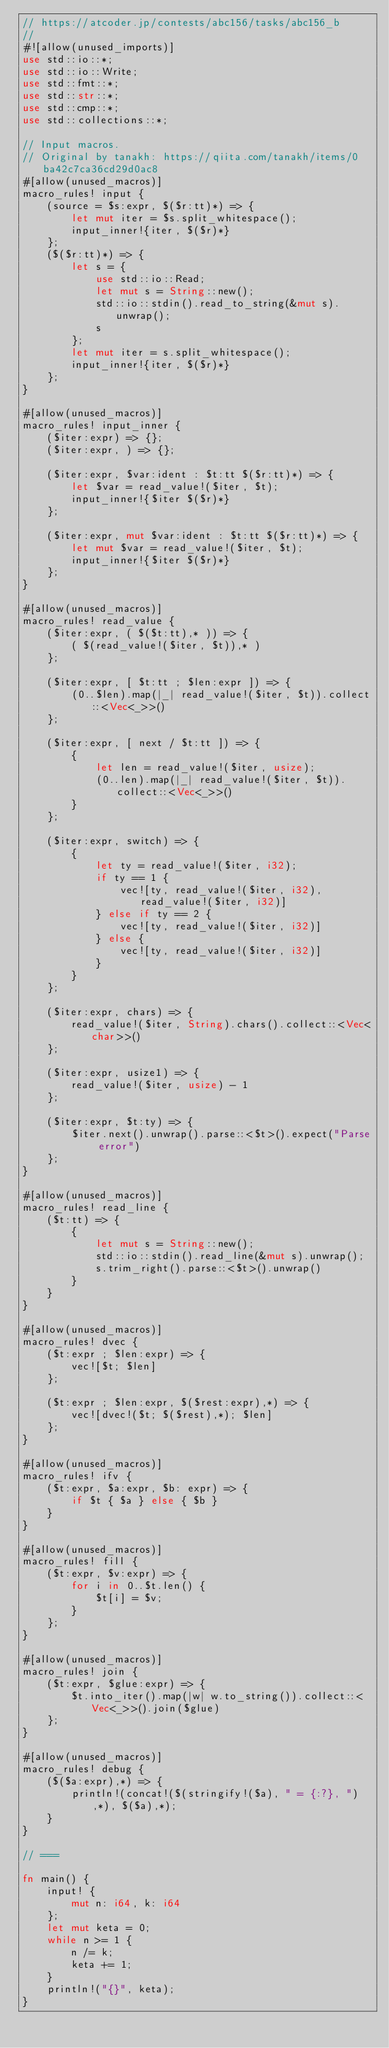Convert code to text. <code><loc_0><loc_0><loc_500><loc_500><_Rust_>// https://atcoder.jp/contests/abc156/tasks/abc156_b
//
#![allow(unused_imports)]
use std::io::*;
use std::io::Write;
use std::fmt::*;
use std::str::*;
use std::cmp::*;
use std::collections::*;

// Input macros.
// Original by tanakh: https://qiita.com/tanakh/items/0ba42c7ca36cd29d0ac8
#[allow(unused_macros)]
macro_rules! input {
    (source = $s:expr, $($r:tt)*) => {
        let mut iter = $s.split_whitespace();
        input_inner!{iter, $($r)*}
    };
    ($($r:tt)*) => {
        let s = {
            use std::io::Read;
            let mut s = String::new();
            std::io::stdin().read_to_string(&mut s).unwrap();
            s
        };
        let mut iter = s.split_whitespace();
        input_inner!{iter, $($r)*}
    };
}

#[allow(unused_macros)]
macro_rules! input_inner {
    ($iter:expr) => {};
    ($iter:expr, ) => {};

    ($iter:expr, $var:ident : $t:tt $($r:tt)*) => {
        let $var = read_value!($iter, $t);
        input_inner!{$iter $($r)*}
    };

    ($iter:expr, mut $var:ident : $t:tt $($r:tt)*) => {
        let mut $var = read_value!($iter, $t);
        input_inner!{$iter $($r)*}
    };
}

#[allow(unused_macros)]
macro_rules! read_value {
    ($iter:expr, ( $($t:tt),* )) => {
        ( $(read_value!($iter, $t)),* )
    };

    ($iter:expr, [ $t:tt ; $len:expr ]) => {
        (0..$len).map(|_| read_value!($iter, $t)).collect::<Vec<_>>()
    };

    ($iter:expr, [ next / $t:tt ]) => {
        {
            let len = read_value!($iter, usize);
            (0..len).map(|_| read_value!($iter, $t)).collect::<Vec<_>>()
        }
    };

    ($iter:expr, switch) => {
        {
            let ty = read_value!($iter, i32);
            if ty == 1 {
                vec![ty, read_value!($iter, i32), read_value!($iter, i32)]
            } else if ty == 2 {
                vec![ty, read_value!($iter, i32)]
            } else {
                vec![ty, read_value!($iter, i32)]
            }
        }
    };

    ($iter:expr, chars) => {
        read_value!($iter, String).chars().collect::<Vec<char>>()
    };

    ($iter:expr, usize1) => {
        read_value!($iter, usize) - 1
    };

    ($iter:expr, $t:ty) => {
        $iter.next().unwrap().parse::<$t>().expect("Parse error")
    };
}

#[allow(unused_macros)]
macro_rules! read_line {
    ($t:tt) => {
        {
            let mut s = String::new();
            std::io::stdin().read_line(&mut s).unwrap();
            s.trim_right().parse::<$t>().unwrap()
        }
    }
}

#[allow(unused_macros)]
macro_rules! dvec {
    ($t:expr ; $len:expr) => {
        vec![$t; $len]
    };

    ($t:expr ; $len:expr, $($rest:expr),*) => {
        vec![dvec!($t; $($rest),*); $len]
    };
}

#[allow(unused_macros)]
macro_rules! ifv {
    ($t:expr, $a:expr, $b: expr) => {
        if $t { $a } else { $b }
    }
}

#[allow(unused_macros)]
macro_rules! fill {
    ($t:expr, $v:expr) => {
        for i in 0..$t.len() {
            $t[i] = $v;
        }
    };
}

#[allow(unused_macros)]
macro_rules! join {
    ($t:expr, $glue:expr) => {
        $t.into_iter().map(|w| w.to_string()).collect::<Vec<_>>().join($glue)
    };
}

#[allow(unused_macros)]
macro_rules! debug {
    ($($a:expr),*) => {
        println!(concat!($(stringify!($a), " = {:?}, "),*), $($a),*);
    }
}

// ===

fn main() {
    input! {
        mut n: i64, k: i64
    };
    let mut keta = 0;
    while n >= 1 {
        n /= k;
        keta += 1;
    }
    println!("{}", keta);
}
</code> 